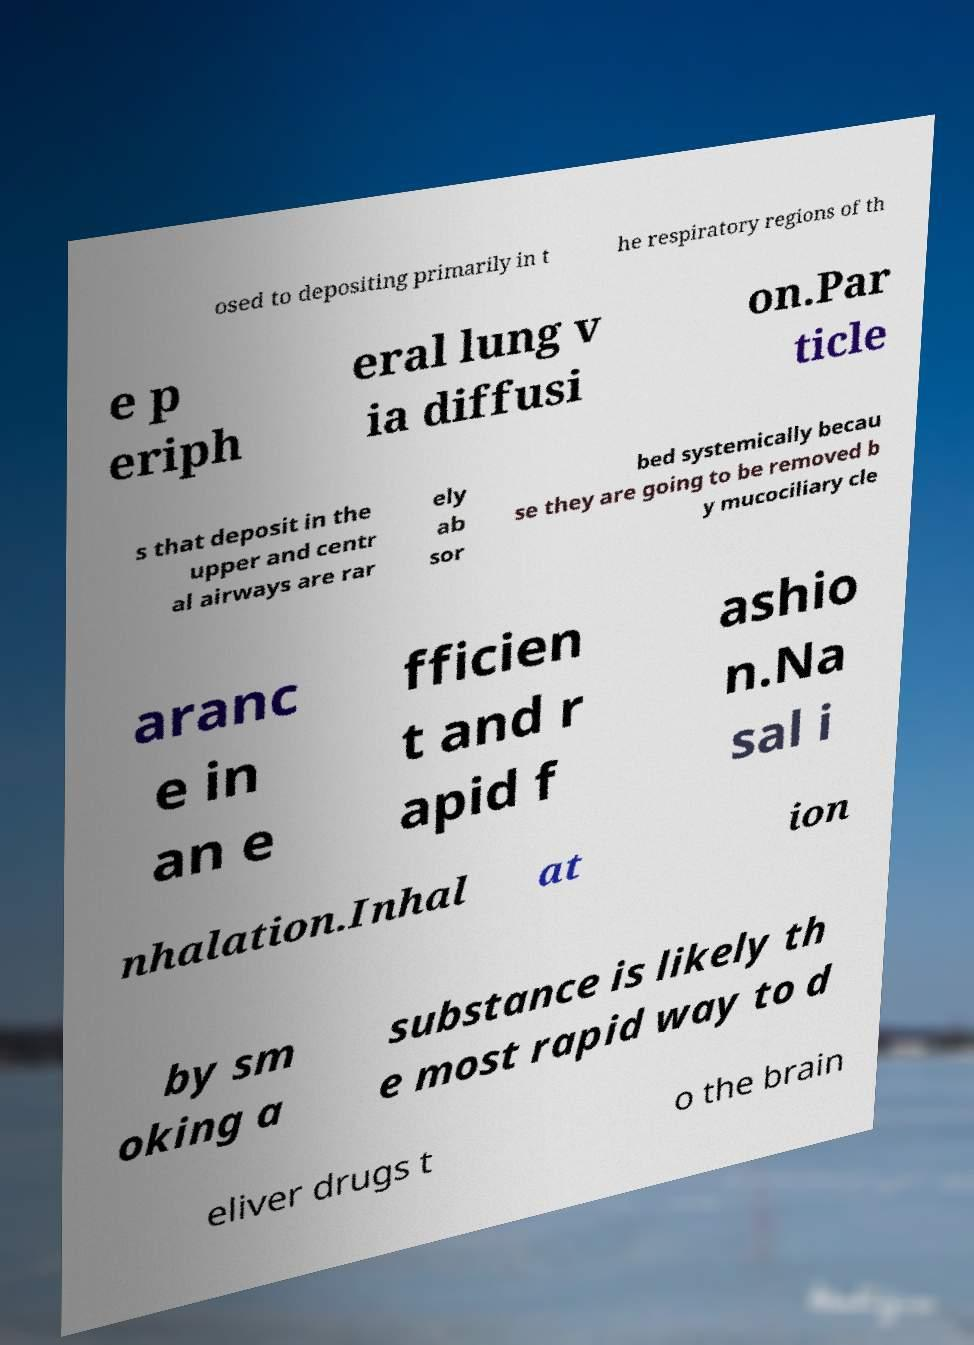I need the written content from this picture converted into text. Can you do that? osed to depositing primarily in t he respiratory regions of th e p eriph eral lung v ia diffusi on.Par ticle s that deposit in the upper and centr al airways are rar ely ab sor bed systemically becau se they are going to be removed b y mucociliary cle aranc e in an e fficien t and r apid f ashio n.Na sal i nhalation.Inhal at ion by sm oking a substance is likely th e most rapid way to d eliver drugs t o the brain 